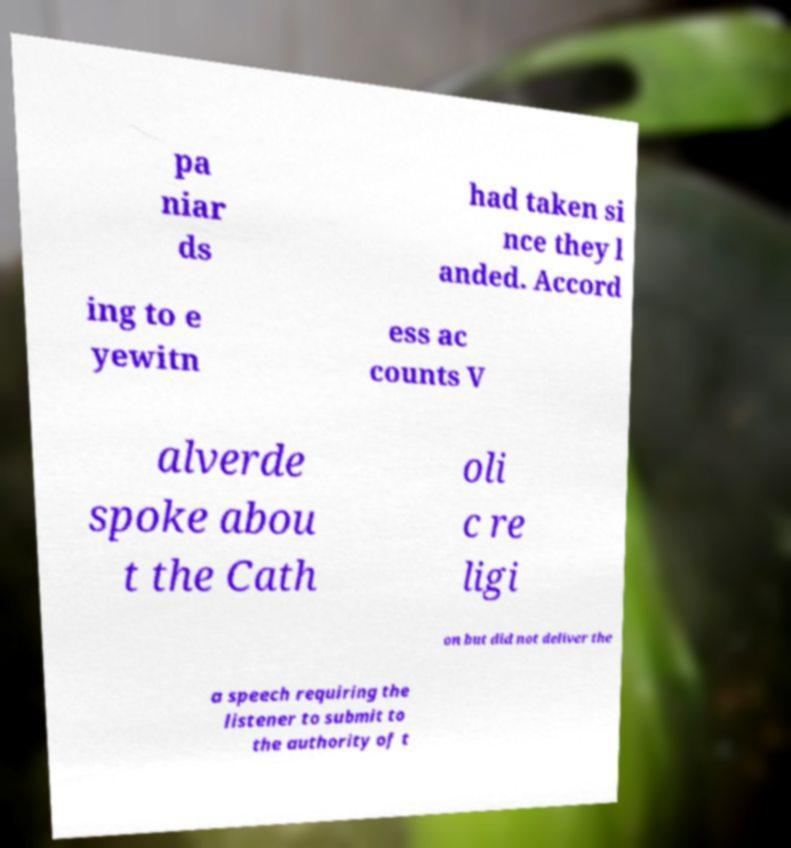I need the written content from this picture converted into text. Can you do that? pa niar ds had taken si nce they l anded. Accord ing to e yewitn ess ac counts V alverde spoke abou t the Cath oli c re ligi on but did not deliver the a speech requiring the listener to submit to the authority of t 